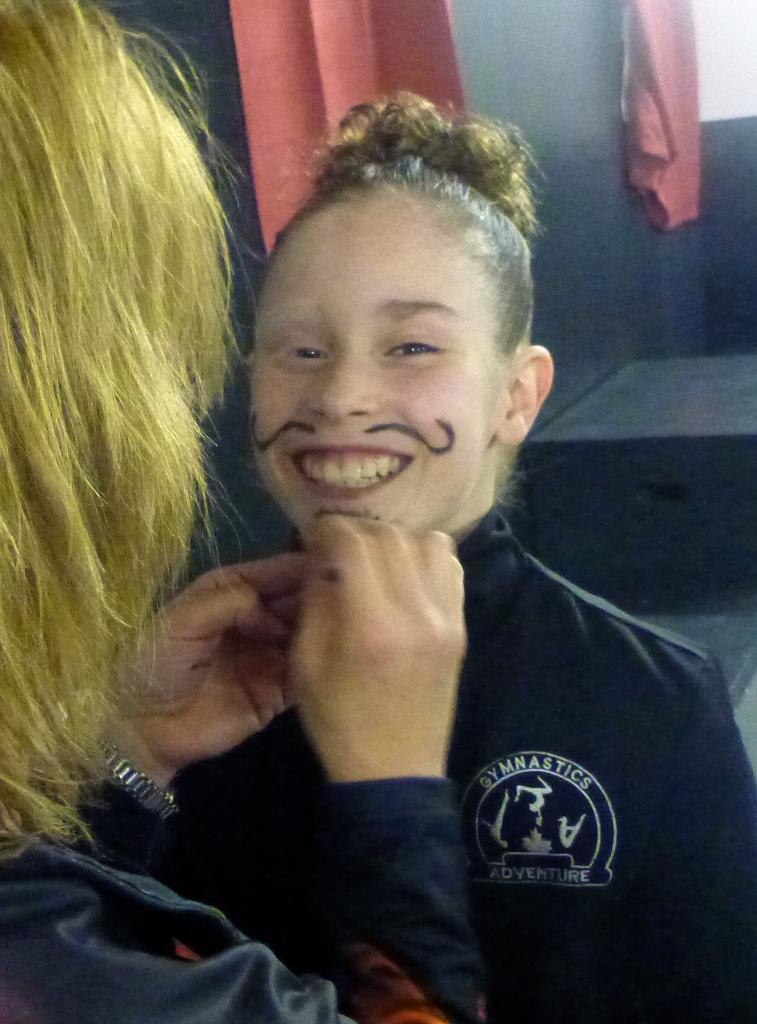How many people are present in the image? There are two people in the image. What are the people wearing? The people are wearing jackets. What can be seen in the background of the image? There is a wall and curtains in the background of the image. What type of anger is being displayed by the beast in the image? There is no beast present in the image, and therefore no anger can be observed. 